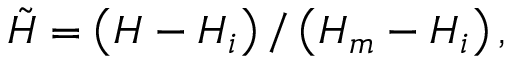Convert formula to latex. <formula><loc_0><loc_0><loc_500><loc_500>\tilde { H } = \left ( H - H _ { i } \right ) / \left ( H _ { m } - H _ { i } \right ) ,</formula> 